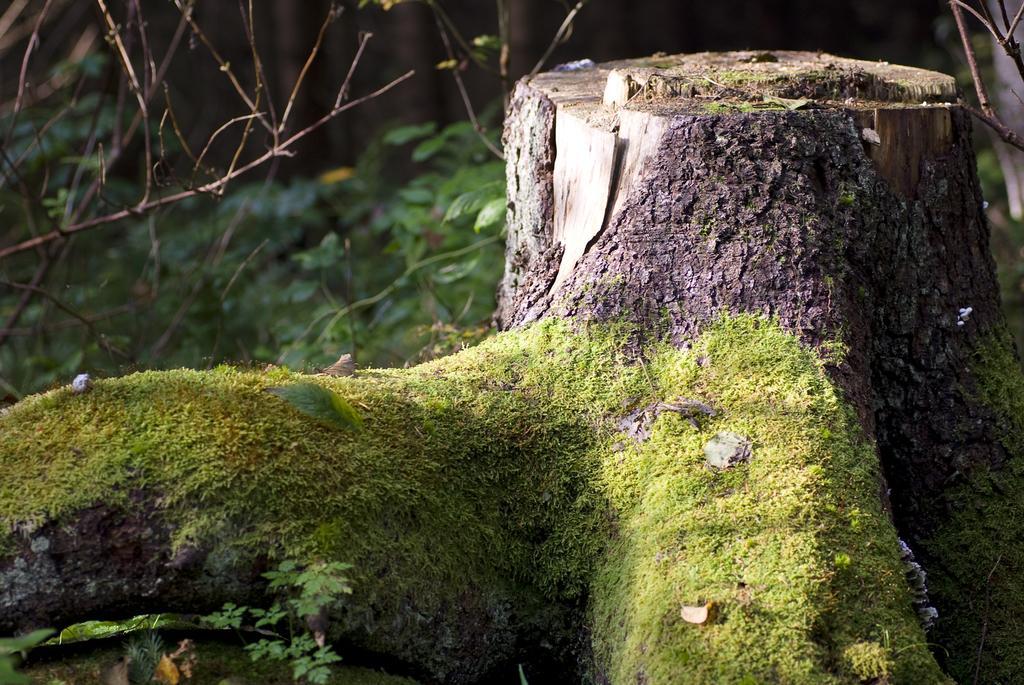In one or two sentences, can you explain what this image depicts? In this image we can see the trunk of a tree, plants and grass. 